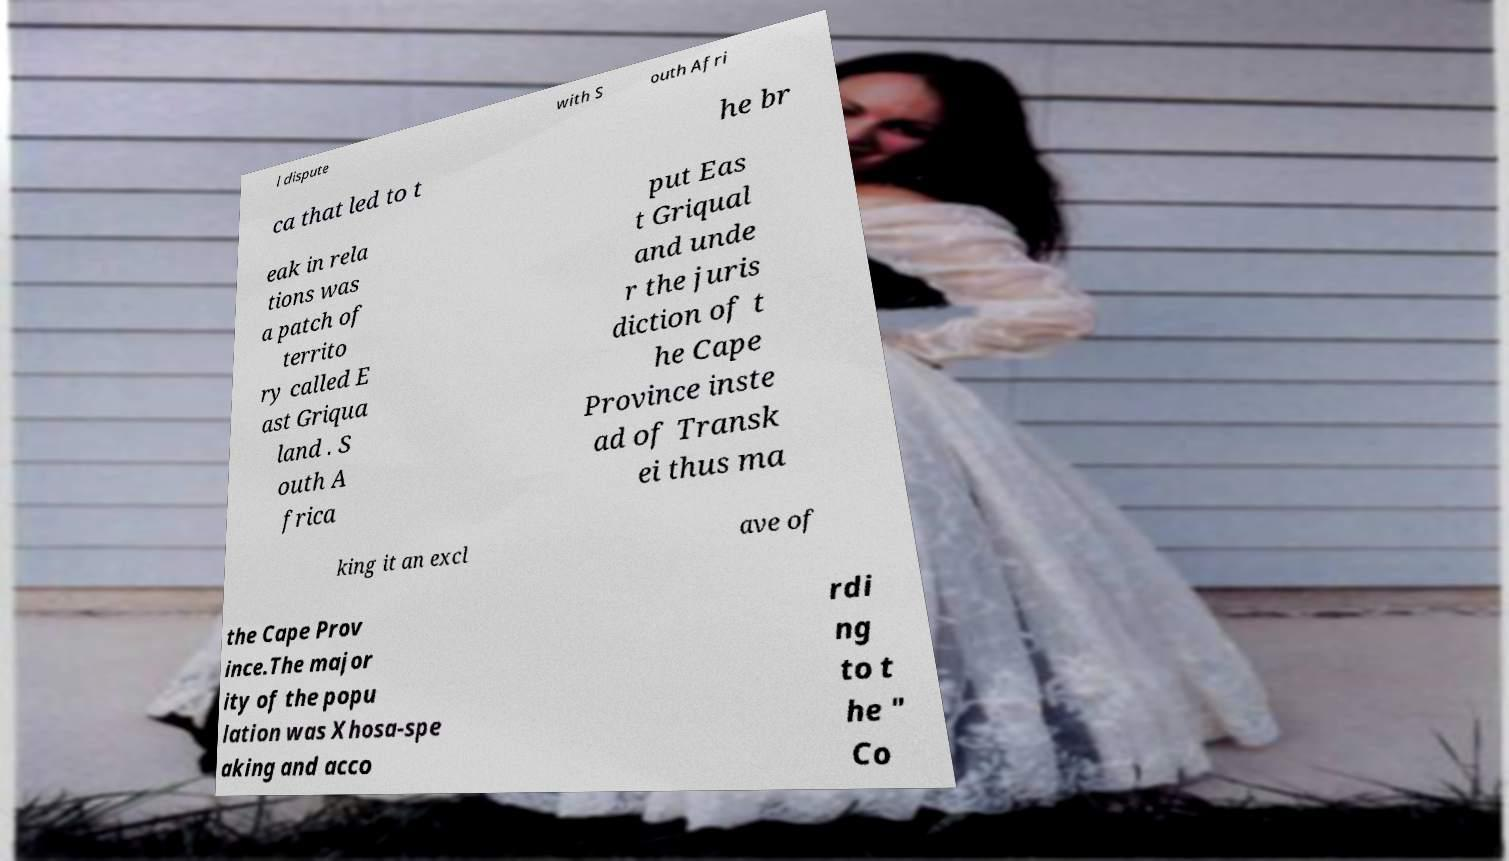For documentation purposes, I need the text within this image transcribed. Could you provide that? l dispute with S outh Afri ca that led to t he br eak in rela tions was a patch of territo ry called E ast Griqua land . S outh A frica put Eas t Griqual and unde r the juris diction of t he Cape Province inste ad of Transk ei thus ma king it an excl ave of the Cape Prov ince.The major ity of the popu lation was Xhosa-spe aking and acco rdi ng to t he " Co 